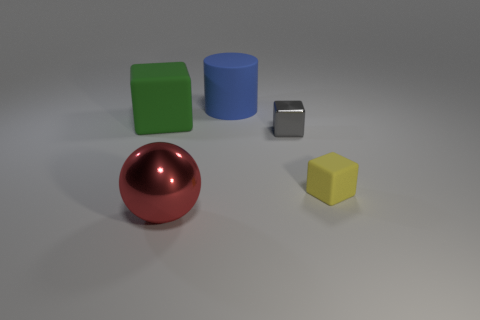Add 1 big blue blocks. How many objects exist? 6 Subtract all green cubes. Subtract all gray cylinders. How many cubes are left? 2 Subtract all cylinders. How many objects are left? 4 Subtract 0 purple cylinders. How many objects are left? 5 Subtract all blue matte cylinders. Subtract all large cyan rubber balls. How many objects are left? 4 Add 3 gray blocks. How many gray blocks are left? 4 Add 2 red things. How many red things exist? 3 